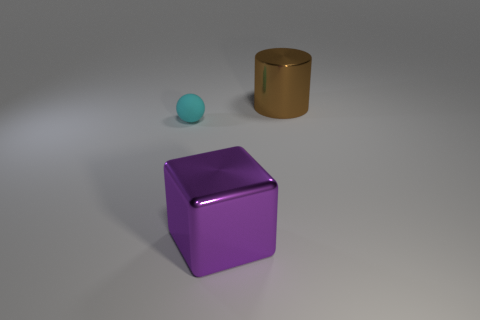Are there any rubber spheres left of the object that is left of the large purple metallic object?
Offer a terse response. No. Are there more big brown things left of the brown metal cylinder than cylinders that are in front of the large block?
Provide a succinct answer. No. There is a large thing that is the same material as the cube; what is its shape?
Provide a succinct answer. Cylinder. There is a thing in front of the matte object; is its size the same as the large brown shiny thing?
Give a very brief answer. Yes. There is a metallic object behind the purple shiny object; what is its size?
Offer a terse response. Large. Do the big shiny block and the small thing have the same color?
Offer a terse response. No. What is the color of the object that is on the right side of the rubber ball and on the left side of the brown object?
Keep it short and to the point. Purple. There is a big object behind the purple thing; what number of small rubber objects are behind it?
Ensure brevity in your answer.  0. What size is the cylinder that is the same material as the purple object?
Ensure brevity in your answer.  Large. Are the tiny ball and the big cube made of the same material?
Keep it short and to the point. No. 